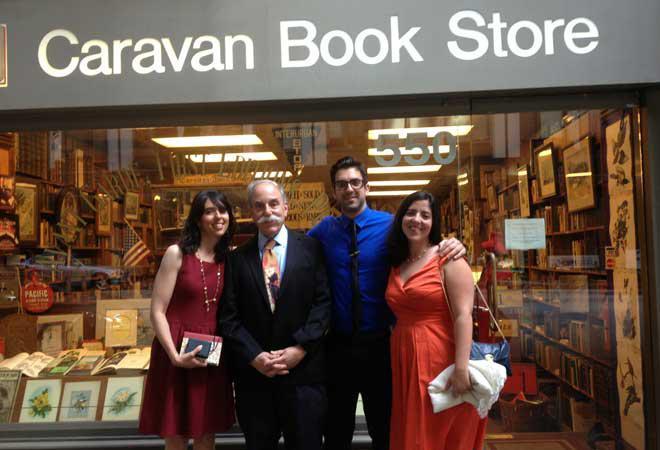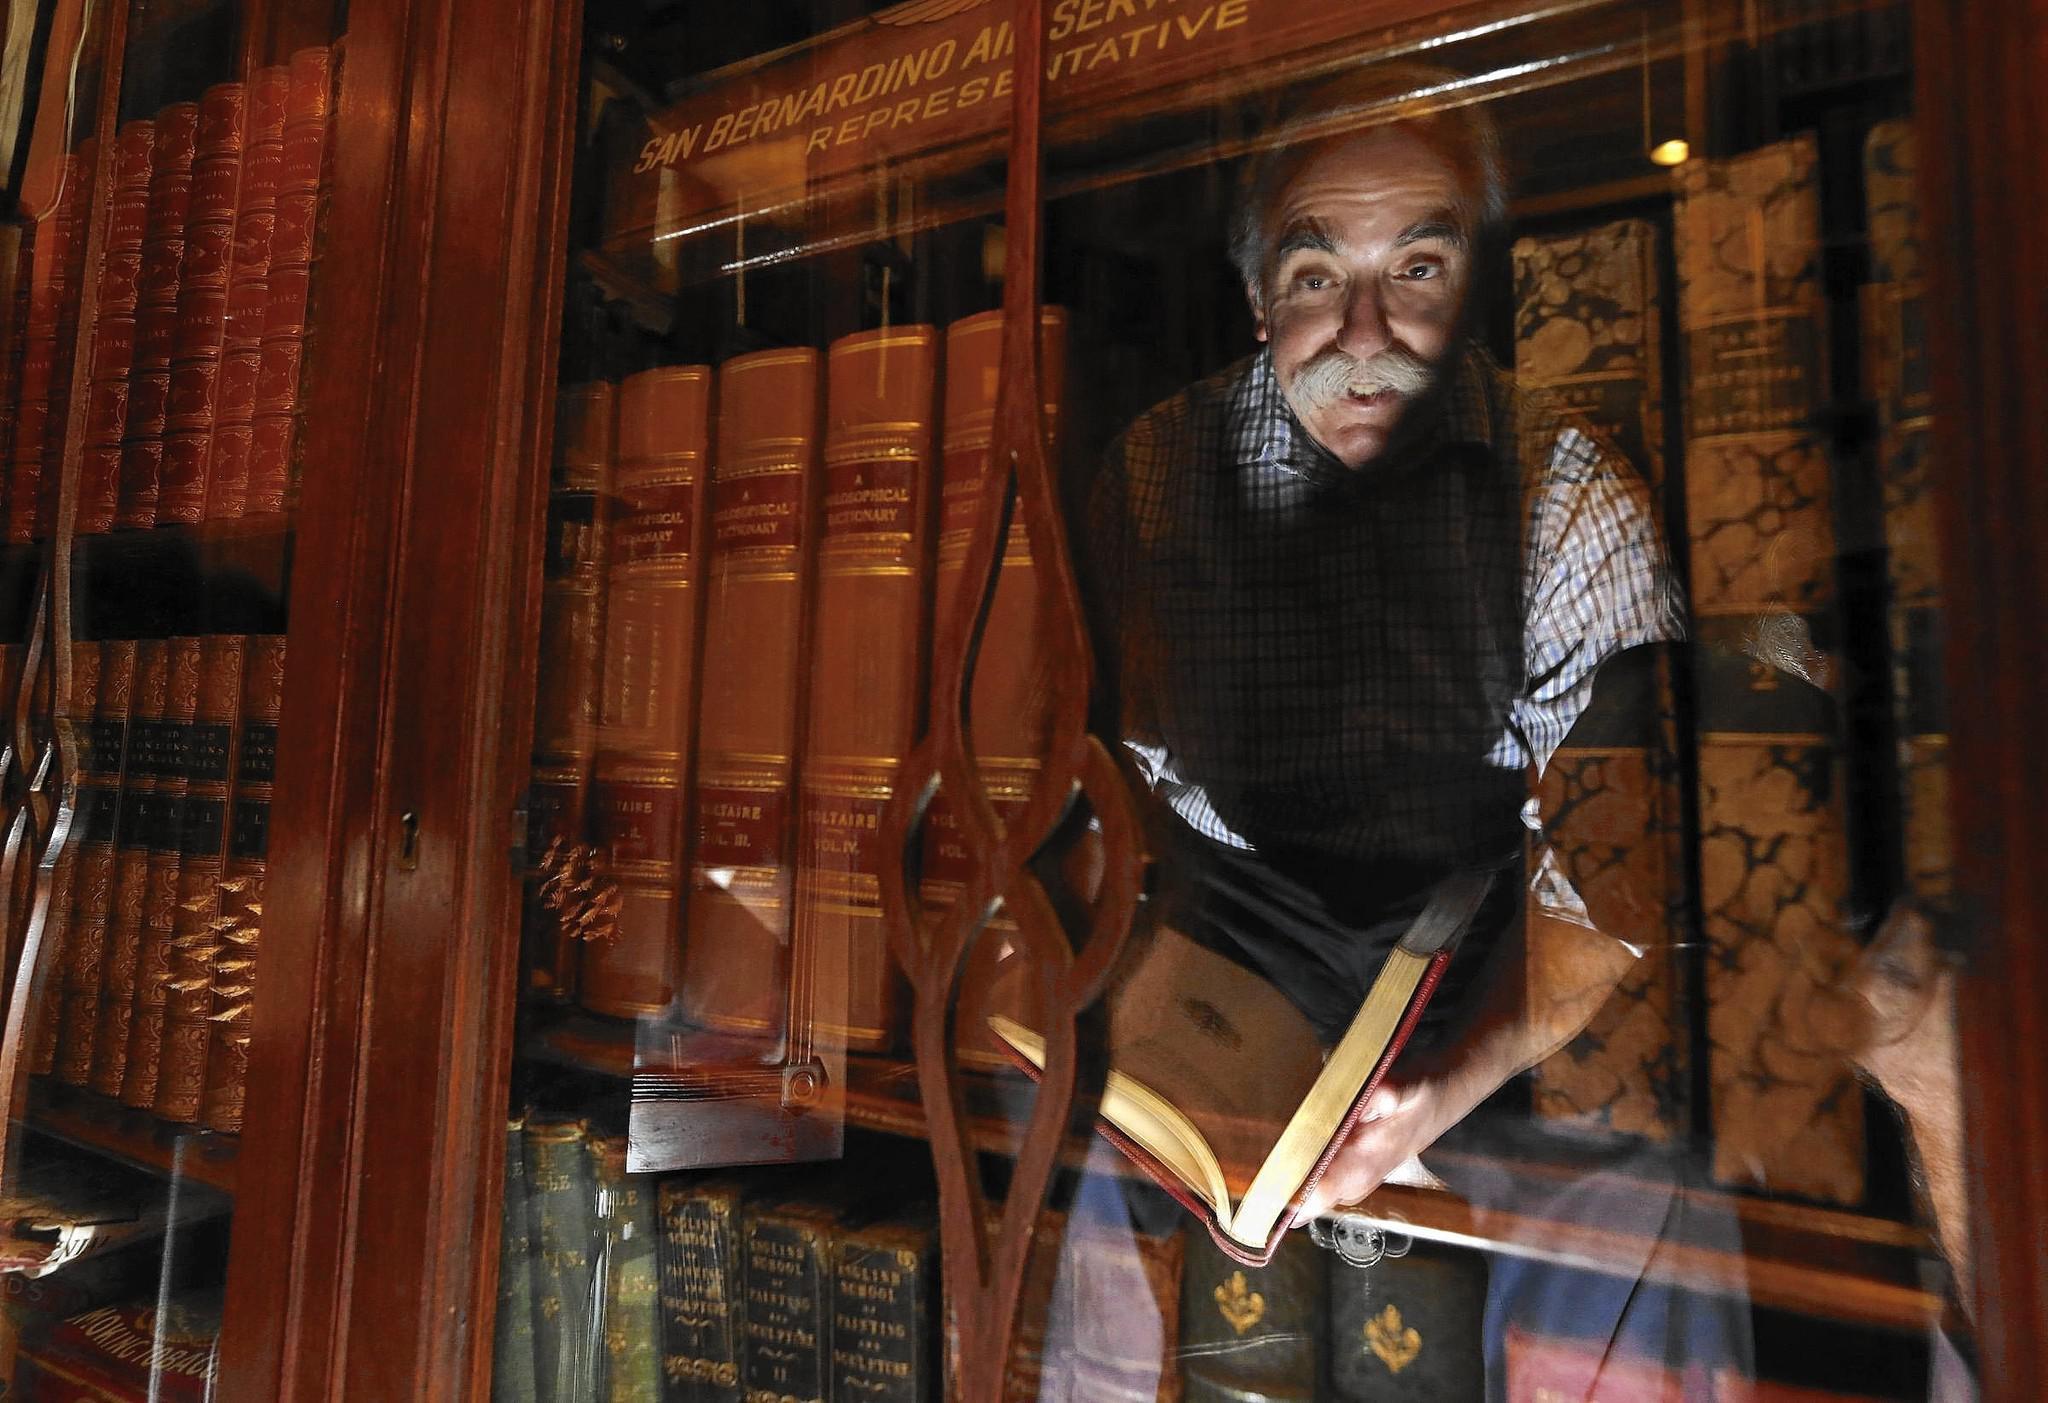The first image is the image on the left, the second image is the image on the right. Considering the images on both sides, is "A man is near some books." valid? Answer yes or no. Yes. 